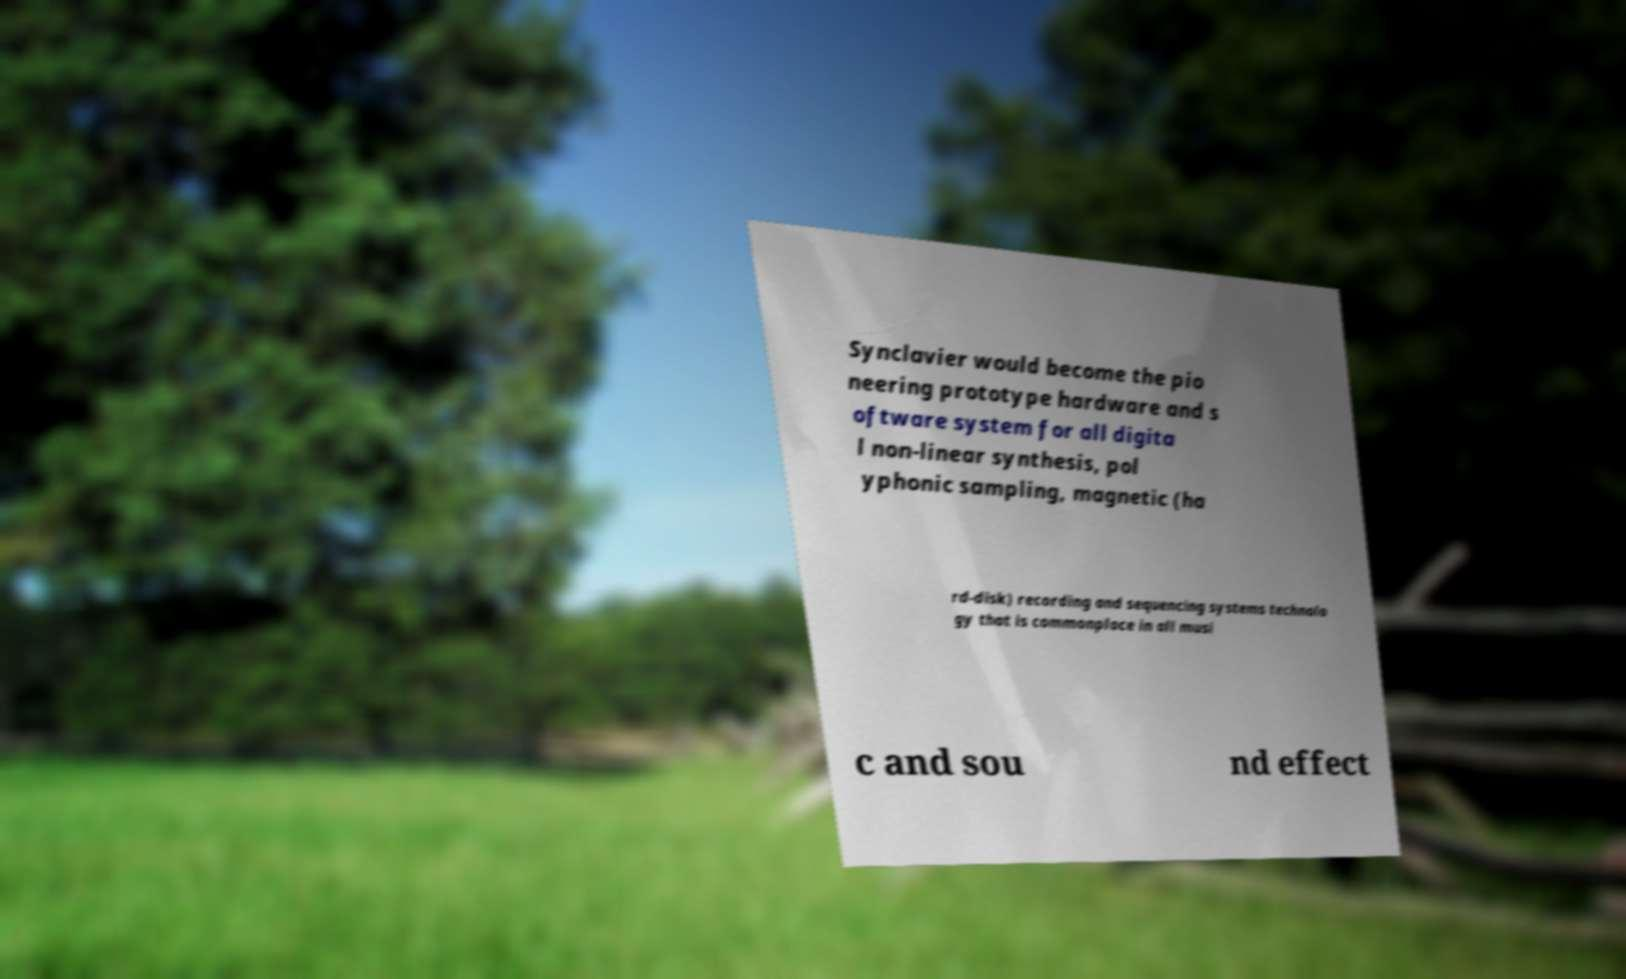Please identify and transcribe the text found in this image. Synclavier would become the pio neering prototype hardware and s oftware system for all digita l non-linear synthesis, pol yphonic sampling, magnetic (ha rd-disk) recording and sequencing systems technolo gy that is commonplace in all musi c and sou nd effect 